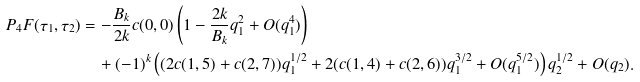Convert formula to latex. <formula><loc_0><loc_0><loc_500><loc_500>P _ { 4 } F ( \tau _ { 1 } , \tau _ { 2 } ) & = - \frac { B _ { k } } { 2 k } c ( 0 , 0 ) \left ( 1 - \frac { 2 k } { B _ { k } } q _ { 1 } ^ { 2 } + O ( q _ { 1 } ^ { 4 } ) \right ) \\ & \quad + ( - 1 ) ^ { k } \left ( ( 2 c ( 1 , 5 ) + c ( 2 , 7 ) ) q _ { 1 } ^ { 1 / 2 } + 2 ( c ( 1 , 4 ) + c ( 2 , 6 ) ) q _ { 1 } ^ { 3 / 2 } + O ( q _ { 1 } ^ { 5 / 2 } ) \right ) q _ { 2 } ^ { 1 / 2 } + O ( q _ { 2 } ) .</formula> 